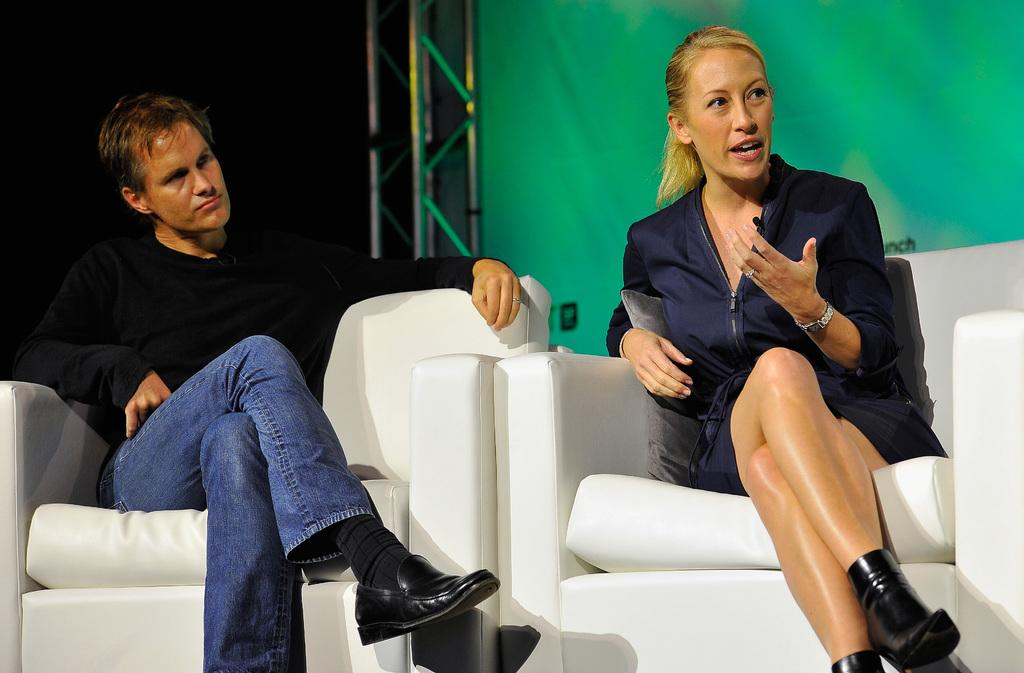How many people are in the image? There are two people in the image. What are the two people doing in the image? The two people are sitting on chairs. What type of pipe can be seen connecting the two people in the image? There is no pipe connecting the two people in the image; they are simply sitting on chairs. 